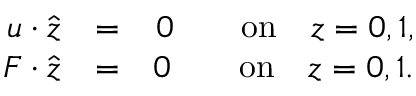<formula> <loc_0><loc_0><loc_500><loc_500>\begin{array} { r l r } { { { \boldsymbol } u } { \boldsymbol \cdot } { \hat { { \boldsymbol } z } } } & { = } & { 0 \quad o n \quad z = 0 , 1 , } \\ { { { \boldsymbol } F } { \boldsymbol \cdot } { \hat { { \boldsymbol } z } } } & { = } & { 0 \quad o n \quad z = 0 , 1 . } \end{array}</formula> 